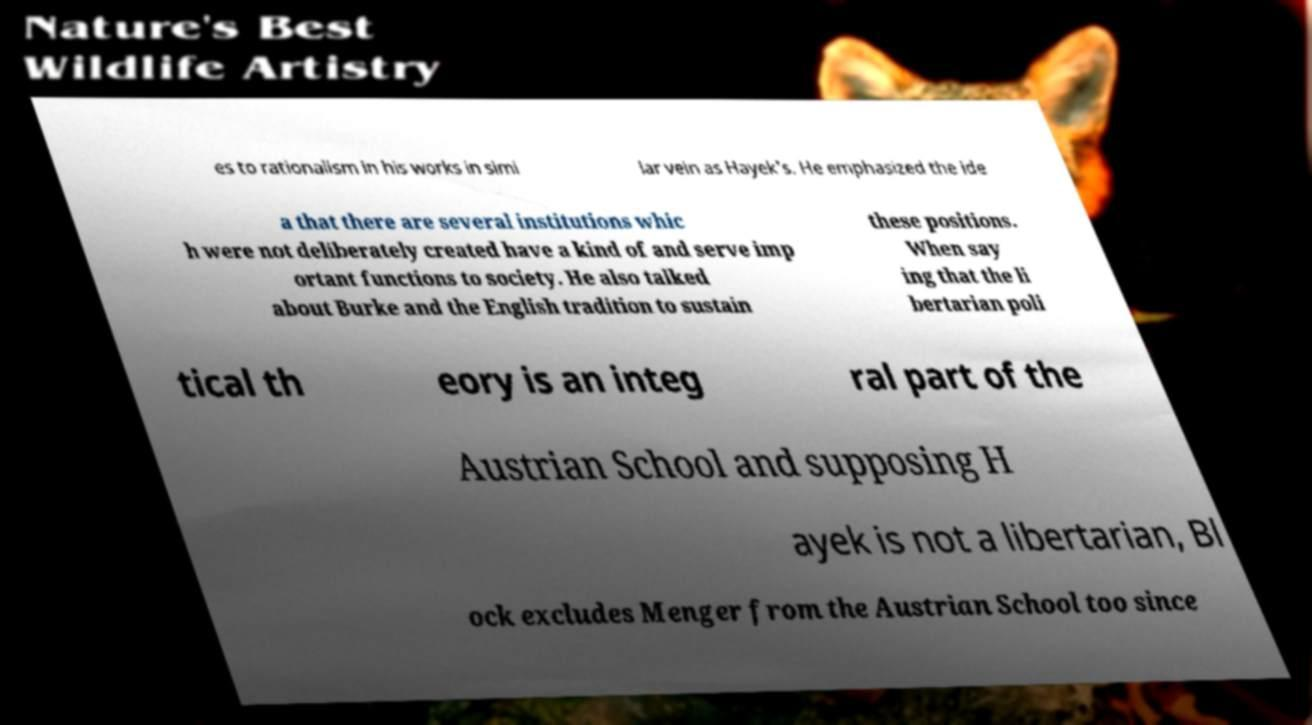What messages or text are displayed in this image? I need them in a readable, typed format. es to rationalism in his works in simi lar vein as Hayek's. He emphasized the ide a that there are several institutions whic h were not deliberately created have a kind of and serve imp ortant functions to society. He also talked about Burke and the English tradition to sustain these positions. When say ing that the li bertarian poli tical th eory is an integ ral part of the Austrian School and supposing H ayek is not a libertarian, Bl ock excludes Menger from the Austrian School too since 